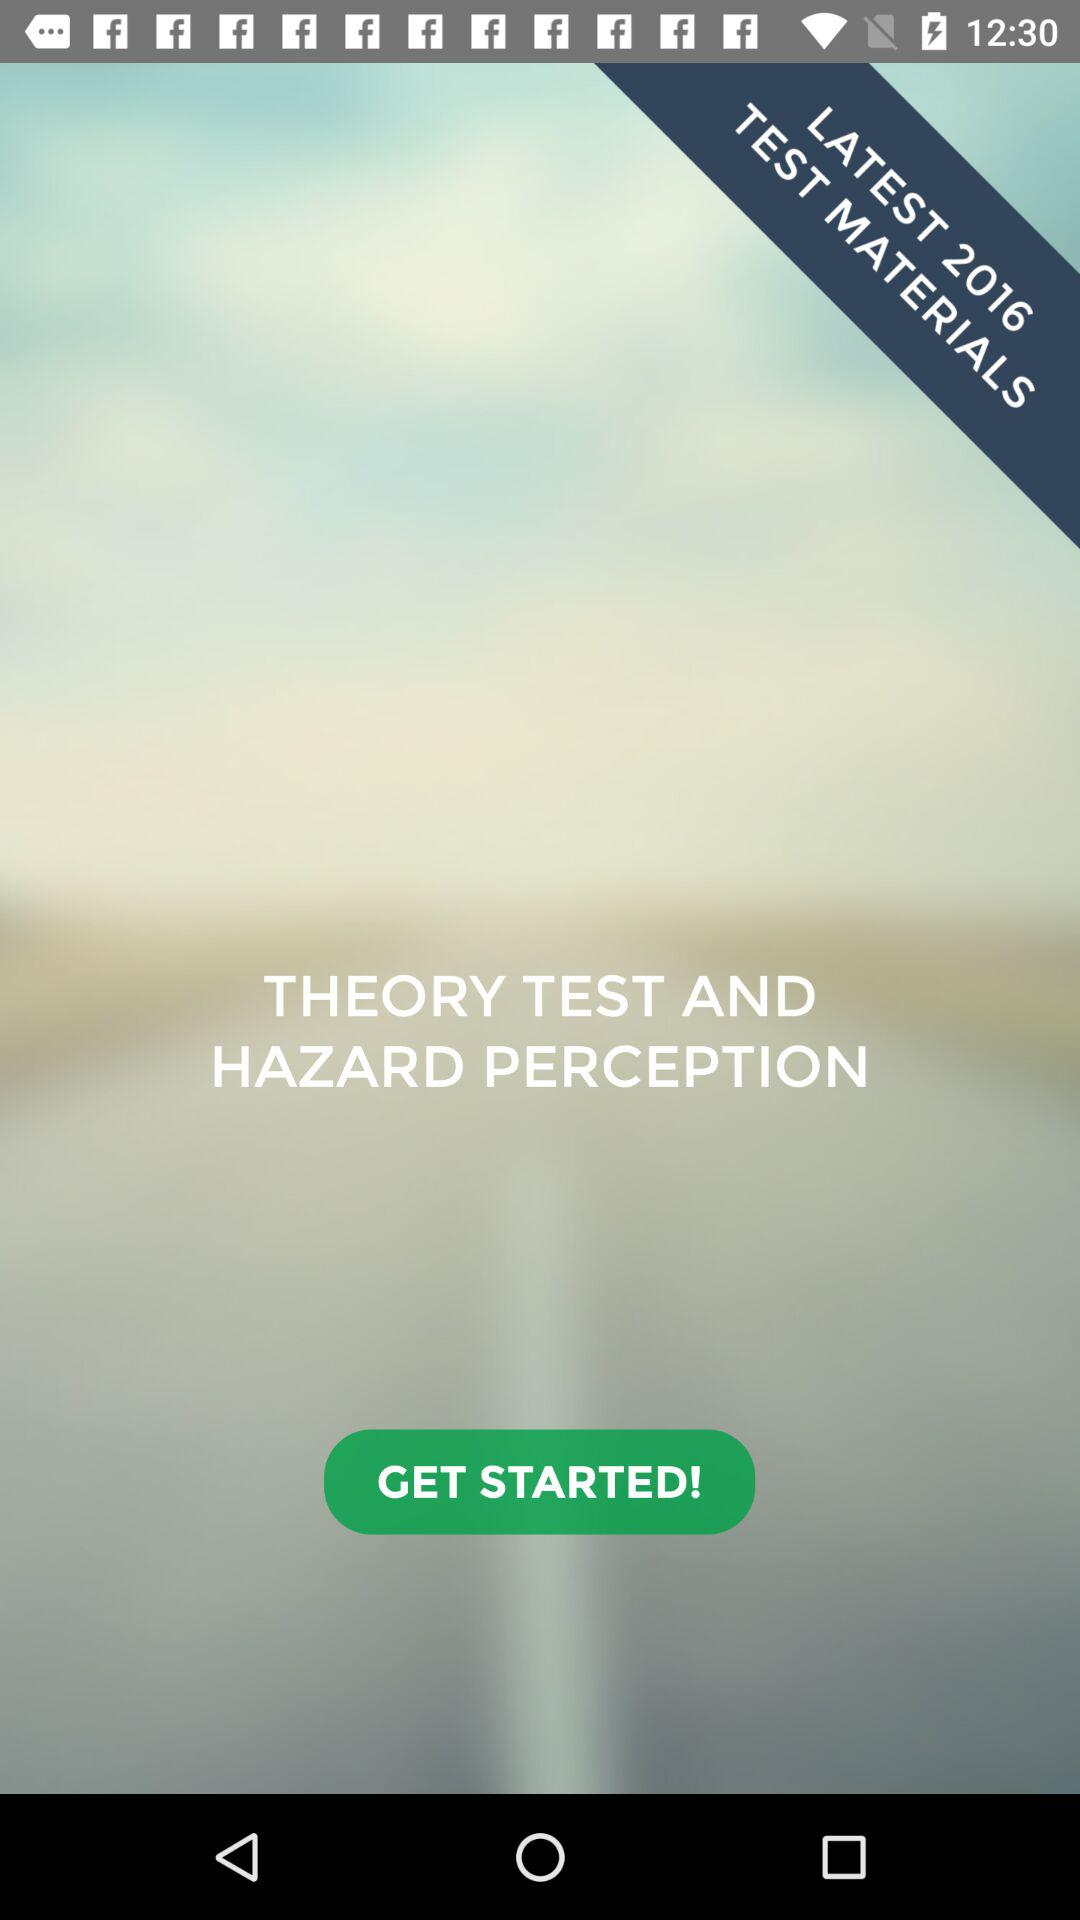What year's latest test materials are available? The latest test materials are available for 2016. 